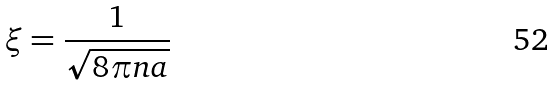Convert formula to latex. <formula><loc_0><loc_0><loc_500><loc_500>\xi = \frac { 1 } { \sqrt { 8 \pi n a } }</formula> 